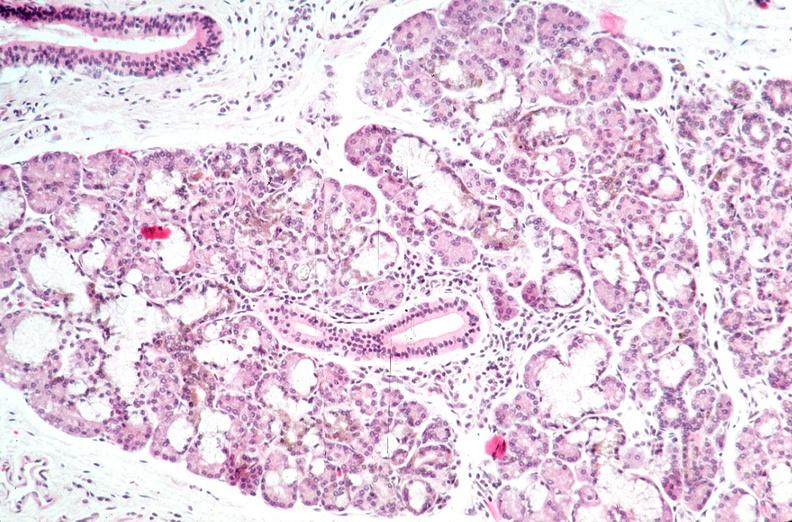where is this?
Answer the question using a single word or phrase. Pancreas 